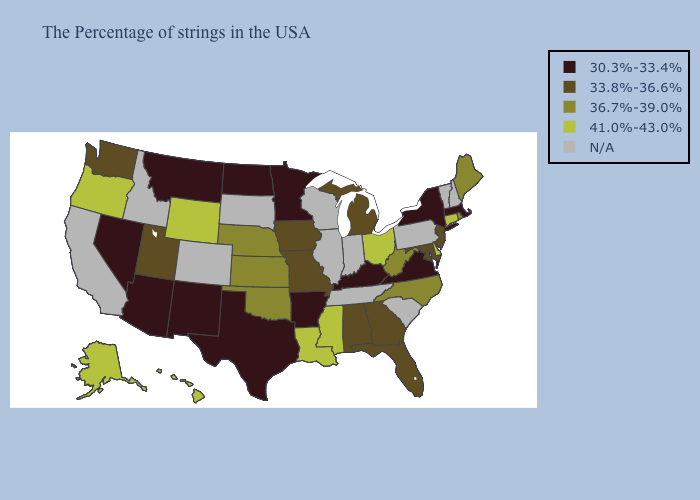Among the states that border New Jersey , which have the highest value?
Concise answer only. Delaware. Name the states that have a value in the range N/A?
Quick response, please. New Hampshire, Vermont, Pennsylvania, South Carolina, Indiana, Tennessee, Wisconsin, Illinois, South Dakota, Colorado, Idaho, California. Name the states that have a value in the range 41.0%-43.0%?
Answer briefly. Connecticut, Delaware, Ohio, Mississippi, Louisiana, Wyoming, Oregon, Alaska, Hawaii. Among the states that border Kentucky , which have the highest value?
Be succinct. Ohio. What is the highest value in the USA?
Answer briefly. 41.0%-43.0%. Is the legend a continuous bar?
Quick response, please. No. Does Montana have the lowest value in the USA?
Be succinct. Yes. Name the states that have a value in the range 33.8%-36.6%?
Concise answer only. New Jersey, Maryland, Florida, Georgia, Michigan, Alabama, Missouri, Iowa, Utah, Washington. What is the value of Kansas?
Write a very short answer. 36.7%-39.0%. What is the lowest value in states that border Ohio?
Concise answer only. 30.3%-33.4%. Name the states that have a value in the range 41.0%-43.0%?
Quick response, please. Connecticut, Delaware, Ohio, Mississippi, Louisiana, Wyoming, Oregon, Alaska, Hawaii. What is the lowest value in the MidWest?
Write a very short answer. 30.3%-33.4%. Does Ohio have the highest value in the MidWest?
Be succinct. Yes. 